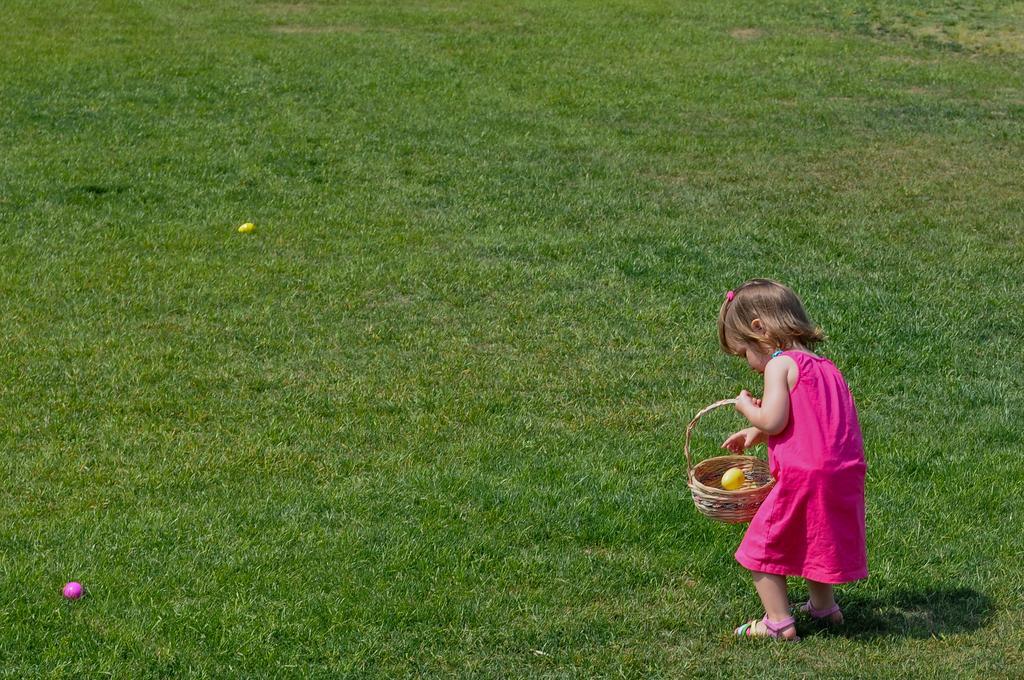How would you summarize this image in a sentence or two? In this image I can see the child standing on the grass. The child is wearing the pink color dress and holding the basket. And I can see the pink and yellow color balls on the grass. 